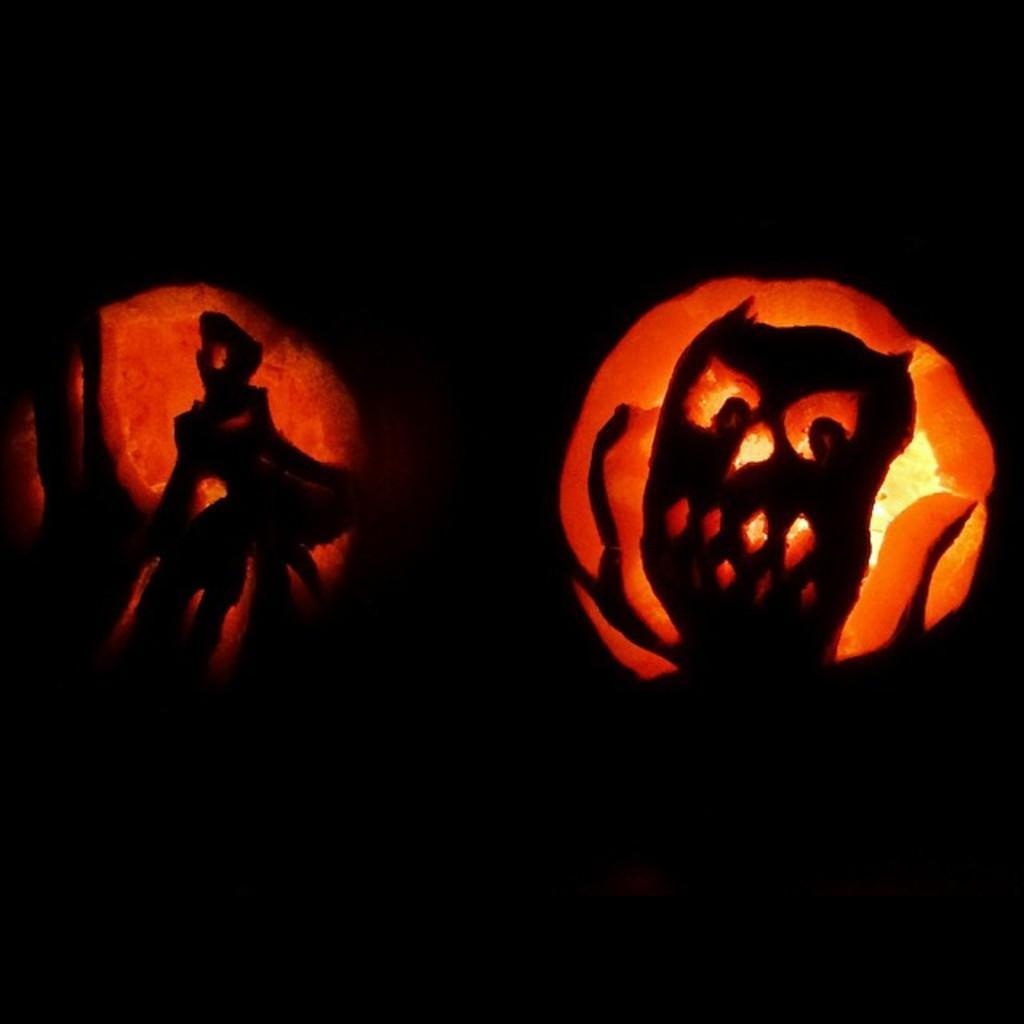In one or two sentences, can you explain what this image depicts? In this image we can see two jack-o-lanterns and the background is blurred. 